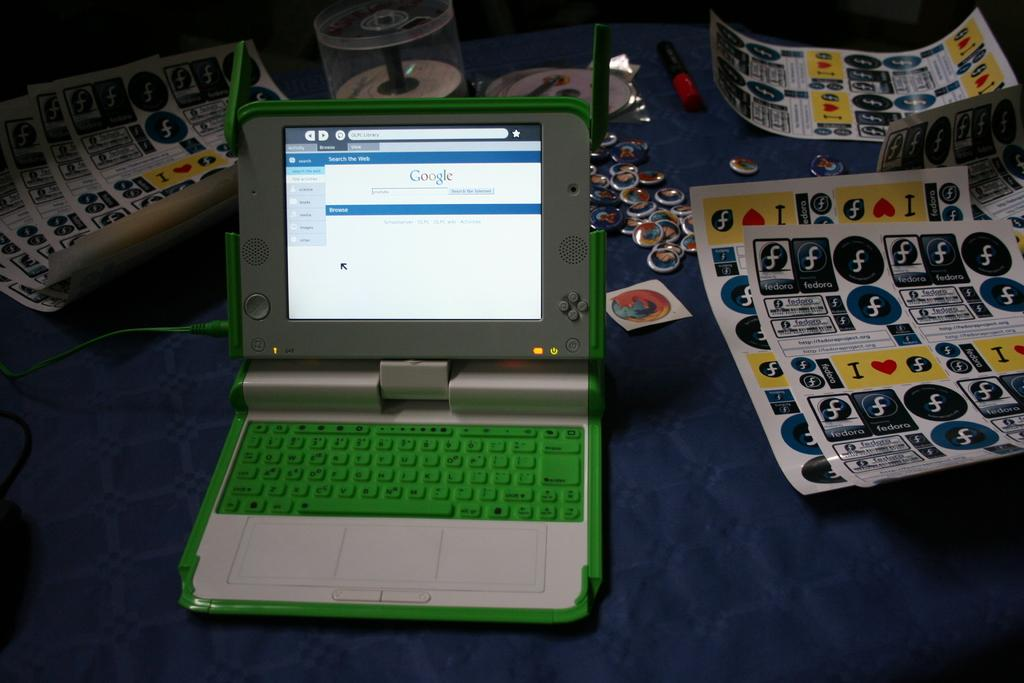Provide a one-sentence caption for the provided image. A small laptop with a green keyboard is open to Google's webpage. 